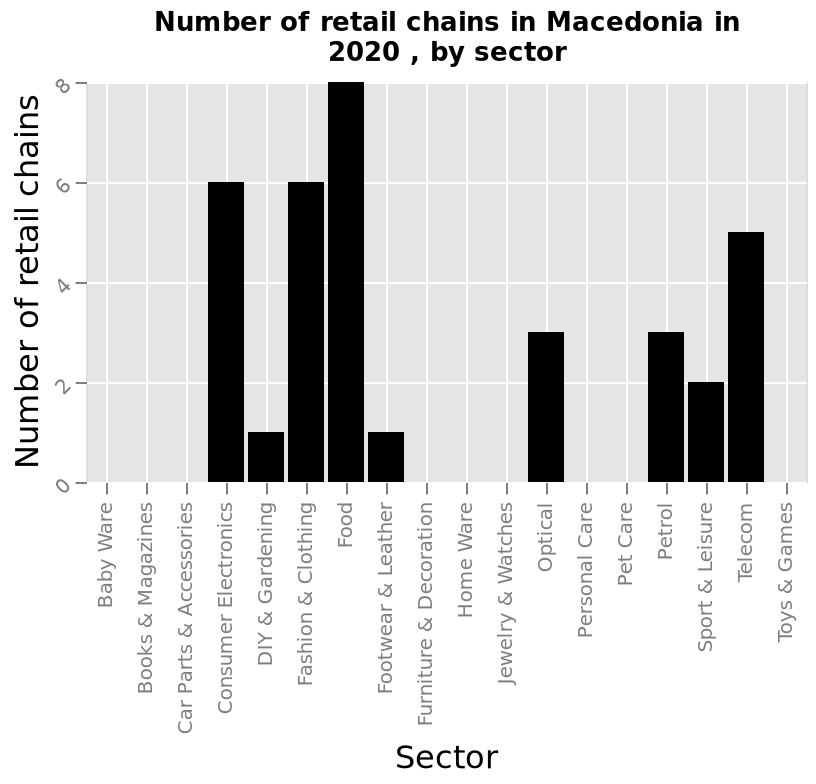<image>
Offer a thorough analysis of the image. Consumer electronics and fashion and clothing both have the same amount of chains 6 each. Food has the most amount of retail chains with 8. DIY and gardening and footwear and leather have the least amount of chains with 1 each. What sector is represented at the highest point on the x-axis?  The sector represented at the highest point on the x-axis is Toys & Games. please enumerates aspects of the construction of the chart Here a bar diagram is named Number of retail chains in Macedonia in 2020 , by sector. The y-axis measures Number of retail chains using linear scale with a minimum of 0 and a maximum of 8 while the x-axis plots Sector with categorical scale from Baby Ware to Toys & Games. 